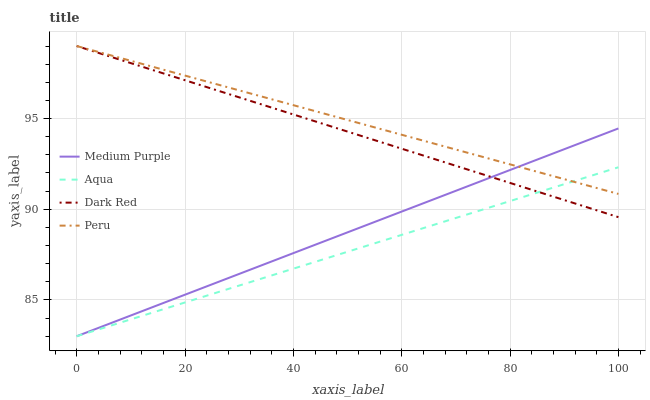Does Aqua have the minimum area under the curve?
Answer yes or no. Yes. Does Peru have the maximum area under the curve?
Answer yes or no. Yes. Does Dark Red have the minimum area under the curve?
Answer yes or no. No. Does Dark Red have the maximum area under the curve?
Answer yes or no. No. Is Medium Purple the smoothest?
Answer yes or no. Yes. Is Aqua the roughest?
Answer yes or no. Yes. Is Dark Red the smoothest?
Answer yes or no. No. Is Dark Red the roughest?
Answer yes or no. No. Does Medium Purple have the lowest value?
Answer yes or no. Yes. Does Dark Red have the lowest value?
Answer yes or no. No. Does Peru have the highest value?
Answer yes or no. Yes. Does Aqua have the highest value?
Answer yes or no. No. Does Peru intersect Dark Red?
Answer yes or no. Yes. Is Peru less than Dark Red?
Answer yes or no. No. Is Peru greater than Dark Red?
Answer yes or no. No. 